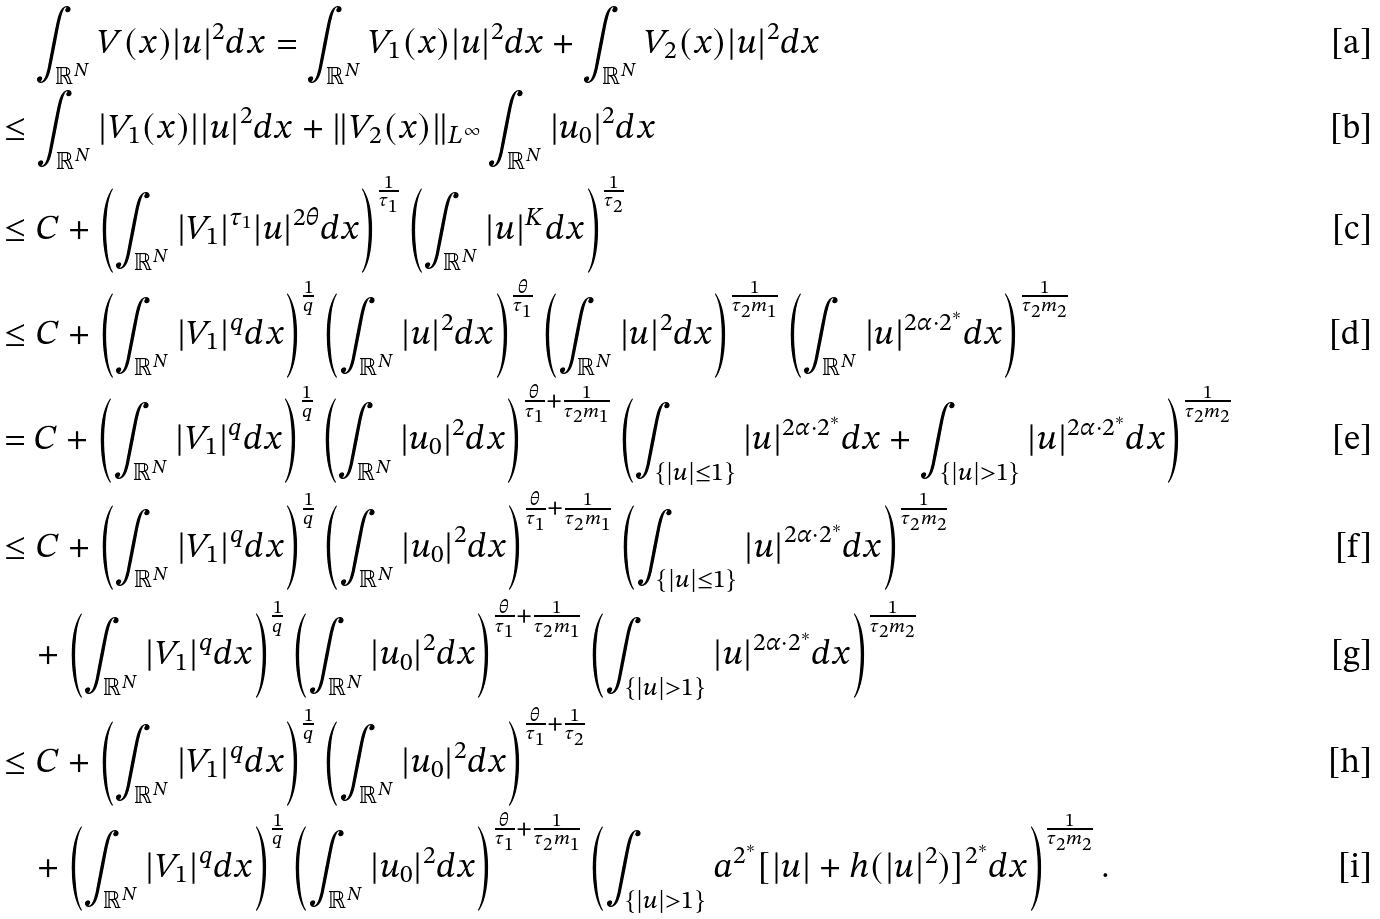<formula> <loc_0><loc_0><loc_500><loc_500>& \quad \int _ { \mathbb { R } ^ { N } } V ( x ) | u | ^ { 2 } d x = \int _ { \mathbb { R } ^ { N } } V _ { 1 } ( x ) | u | ^ { 2 } d x + \int _ { \mathbb { R } ^ { N } } V _ { 2 } ( x ) | u | ^ { 2 } d x \\ & \leq \int _ { \mathbb { R } ^ { N } } | V _ { 1 } ( x ) | | u | ^ { 2 } d x + \| V _ { 2 } ( x ) \| _ { L ^ { \infty } } \int _ { \mathbb { R } ^ { N } } | u _ { 0 } | ^ { 2 } d x \\ & \leq C + \left ( \int _ { \mathbb { R } ^ { N } } | V _ { 1 } | ^ { \tau _ { 1 } } | u | ^ { 2 \theta } d x \right ) ^ { \frac { 1 } { \tau _ { 1 } } } \left ( \int _ { \mathbb { R } ^ { N } } | u | ^ { K } d x \right ) ^ { \frac { 1 } { \tau _ { 2 } } } \\ & \leq C + \left ( \int _ { \mathbb { R } ^ { N } } | V _ { 1 } | ^ { q } d x \right ) ^ { \frac { 1 } { q } } \left ( \int _ { \mathbb { R } ^ { N } } | u | ^ { 2 } d x \right ) ^ { \frac { \theta } { \tau _ { 1 } } } \left ( \int _ { \mathbb { R } ^ { N } } | u | ^ { 2 } d x \right ) ^ { \frac { 1 } { \tau _ { 2 } m _ { 1 } } } \left ( \int _ { \mathbb { R } ^ { N } } | u | ^ { 2 \alpha \cdot 2 ^ { * } } d x \right ) ^ { \frac { 1 } { \tau _ { 2 } m _ { 2 } } } \\ & = C + \left ( \int _ { \mathbb { R } ^ { N } } | V _ { 1 } | ^ { q } d x \right ) ^ { \frac { 1 } { q } } \left ( \int _ { \mathbb { R } ^ { N } } | u _ { 0 } | ^ { 2 } d x \right ) ^ { \frac { \theta } { \tau _ { 1 } } + \frac { 1 } { \tau _ { 2 } m _ { 1 } } } \left ( \int _ { \{ | u | \leq 1 \} } | u | ^ { 2 \alpha \cdot 2 ^ { * } } d x + \int _ { \{ | u | > 1 \} } | u | ^ { 2 \alpha \cdot 2 ^ { * } } d x \right ) ^ { \frac { 1 } { \tau _ { 2 } m _ { 2 } } } \\ & \leq C + \left ( \int _ { \mathbb { R } ^ { N } } | V _ { 1 } | ^ { q } d x \right ) ^ { \frac { 1 } { q } } \left ( \int _ { \mathbb { R } ^ { N } } | u _ { 0 } | ^ { 2 } d x \right ) ^ { \frac { \theta } { \tau _ { 1 } } + \frac { 1 } { \tau _ { 2 } m _ { 1 } } } \left ( \int _ { \{ | u | \leq 1 \} } | u | ^ { 2 \alpha \cdot 2 ^ { * } } d x \right ) ^ { \frac { 1 } { \tau _ { 2 } m _ { 2 } } } \\ & \quad + \left ( \int _ { \mathbb { R } ^ { N } } | V _ { 1 } | ^ { q } d x \right ) ^ { \frac { 1 } { q } } \left ( \int _ { \mathbb { R } ^ { N } } | u _ { 0 } | ^ { 2 } d x \right ) ^ { \frac { \theta } { \tau _ { 1 } } + \frac { 1 } { \tau _ { 2 } m _ { 1 } } } \left ( \int _ { \{ | u | > 1 \} } | u | ^ { 2 \alpha \cdot 2 ^ { * } } d x \right ) ^ { \frac { 1 } { \tau _ { 2 } m _ { 2 } } } \\ & \leq C + \left ( \int _ { \mathbb { R } ^ { N } } | V _ { 1 } | ^ { q } d x \right ) ^ { \frac { 1 } { q } } \left ( \int _ { \mathbb { R } ^ { N } } | u _ { 0 } | ^ { 2 } d x \right ) ^ { \frac { \theta } { \tau _ { 1 } } + \frac { 1 } { \tau _ { 2 } } } \\ & \quad + \left ( \int _ { \mathbb { R } ^ { N } } | V _ { 1 } | ^ { q } d x \right ) ^ { \frac { 1 } { q } } \left ( \int _ { \mathbb { R } ^ { N } } | u _ { 0 } | ^ { 2 } d x \right ) ^ { \frac { \theta } { \tau _ { 1 } } + \frac { 1 } { \tau _ { 2 } m _ { 1 } } } \left ( \int _ { \{ | u | > 1 \} } a ^ { 2 ^ { * } } [ | u | + h ( | u | ^ { 2 } ) ] ^ { 2 ^ { * } } d x \right ) ^ { \frac { 1 } { \tau _ { 2 } m _ { 2 } } } .</formula> 